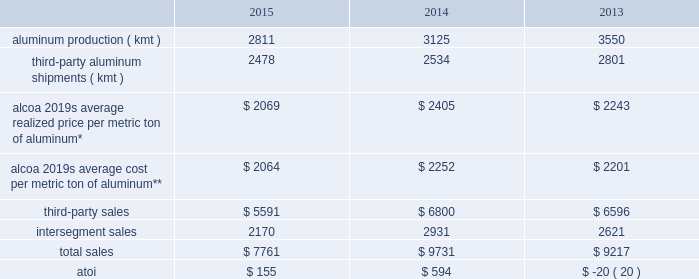In 2016 , alumina production will be approximately 2500 kmt lower , mostly due to the curtailment of the point comfort and suralco refineries .
Also , the continued shift towards alumina index and spot pricing is expected to average 85% ( 85 % ) of third-party smelter-grade alumina shipments .
Additionally , net productivity improvements are anticipated .
Primary metals .
* average realized price per metric ton of aluminum includes three elements : a ) the underlying base metal component , based on quoted prices from the lme ; b ) the regional premium , which represents the incremental price over the base lme component that is associated with the physical delivery of metal to a particular region ( e.g. , the midwest premium for metal sold in the united states ) ; and c ) the product premium , which represents the incremental price for receiving physical metal in a particular shape ( e.g. , billet , slab , rod , etc. ) or alloy .
**includes all production-related costs , including raw materials consumed ; conversion costs , such as labor , materials , and utilities ; depreciation and amortization ; and plant administrative expenses .
This segment represents a portion of alcoa 2019s upstream operations and consists of the company 2019s worldwide smelting system .
Primary metals purchases alumina , mostly from the alumina segment ( see alumina above ) , from which primary aluminum is produced and then sold directly to external customers and traders , as well as to alcoa 2019s midstream operations and , to a lesser extent , downstream operations .
Results from the sale of aluminum powder , scrap , and excess energy are also included in this segment , as well as the results of aluminum derivative contracts and buy/ resell activity .
Primary aluminum produced by alcoa and used internally is transferred to other segments at prevailing market prices .
The sale of primary aluminum represents approximately 90% ( 90 % ) of this segment 2019s third-party sales .
Buy/ resell activity occurs when this segment purchases metal and resells such metal to external customers or the midstream and downstream operations in order to maximize smelting system efficiency and to meet customer requirements .
Generally , the sales of this segment are transacted in u.s .
Dollars while costs and expenses of this segment are transacted in the local currency of the respective operations , which are the u.s .
Dollar , the euro , the norwegian kroner , icelandic krona , the canadian dollar , the brazilian real , and the australian dollar .
In november 2014 , alcoa completed the sale of an aluminum rod plant located in b e9cancour , qu e9bec , canada to sural laminated products .
This facility takes molten aluminum and shapes it into the form of a rod , which is used by customers primarily for the transportation of electricity .
While owned by alcoa , the operating results and assets and liabilities of this plant were included in the primary metals segment .
In conjunction with this transaction , alcoa entered into a multi-year agreement with sural laminated products to supply molten aluminum for the rod plant .
The aluminum rod plant generated sales of approximately $ 200 in 2013 and , at the time of divestiture , had approximately 60 employees .
See restructuring and other charges in results of operations above .
In december 2014 , alcoa completed the sale of its 50.33% ( 50.33 % ) ownership stake in the mt .
Holly smelter located in goose creek , south carolina to century aluminum company .
While owned by alcoa , 50.33% ( 50.33 % ) of both the operating results and assets and liabilities related to the smelter were included in the primary metals segment .
As it relates to alcoa 2019s previous 50.33% ( 50.33 % ) ownership stake , the smelter ( alcoa 2019s share of the capacity was 115 kmt-per-year ) generated sales of approximately $ 280 in 2013 and , at the time of divestiture , had approximately 250 employees .
See restructuring and other charges in results of operations above .
At december 31 , 2015 , alcoa had 778 kmt of idle capacity on a base capacity of 3401 kmt .
In 2015 , idle capacity increased 113 kmt compared to 2014 , mostly due to the curtailment of 217 kmt combined at a smelter in each the .
What was the decrease in the number of dollars obtained with the sale of primary aluminum during 2013 and 2014? 
Rationale: it is the difference between the number of third-party sales of primary aluminum in 2014 and 2013 .
Computations: ((6800 * 90%) - (6596 * 90%))
Answer: 183.6. 